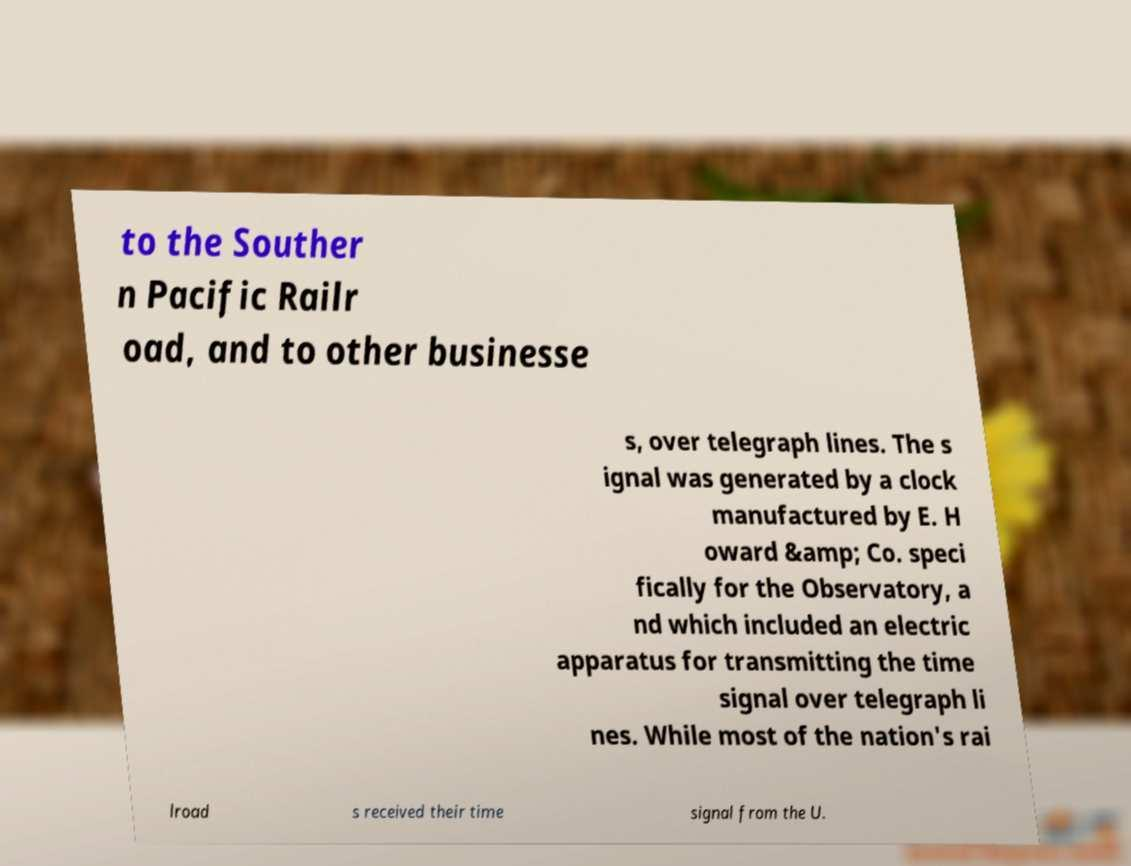Can you read and provide the text displayed in the image?This photo seems to have some interesting text. Can you extract and type it out for me? to the Souther n Pacific Railr oad, and to other businesse s, over telegraph lines. The s ignal was generated by a clock manufactured by E. H oward &amp; Co. speci fically for the Observatory, a nd which included an electric apparatus for transmitting the time signal over telegraph li nes. While most of the nation's rai lroad s received their time signal from the U. 